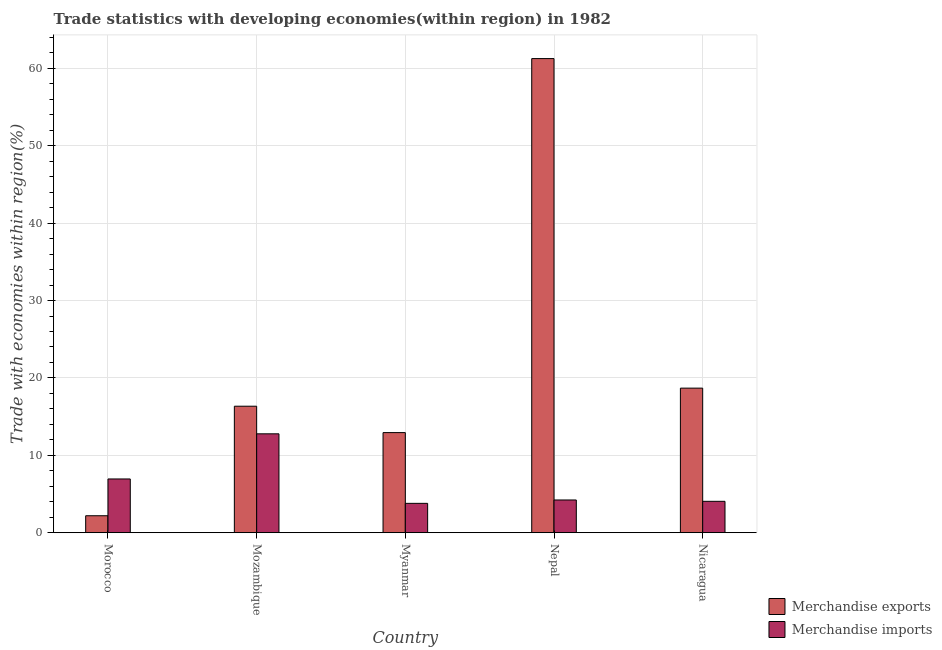How many bars are there on the 2nd tick from the left?
Your response must be concise. 2. How many bars are there on the 4th tick from the right?
Provide a succinct answer. 2. What is the label of the 2nd group of bars from the left?
Your answer should be very brief. Mozambique. What is the merchandise exports in Myanmar?
Make the answer very short. 12.94. Across all countries, what is the maximum merchandise exports?
Your response must be concise. 61.26. Across all countries, what is the minimum merchandise imports?
Offer a terse response. 3.79. In which country was the merchandise imports maximum?
Ensure brevity in your answer.  Mozambique. In which country was the merchandise imports minimum?
Ensure brevity in your answer.  Myanmar. What is the total merchandise imports in the graph?
Offer a very short reply. 31.8. What is the difference between the merchandise exports in Morocco and that in Myanmar?
Make the answer very short. -10.74. What is the difference between the merchandise imports in Nepal and the merchandise exports in Mozambique?
Provide a short and direct response. -12.12. What is the average merchandise exports per country?
Your answer should be compact. 22.28. What is the difference between the merchandise exports and merchandise imports in Nepal?
Your answer should be very brief. 57.03. What is the ratio of the merchandise exports in Morocco to that in Nepal?
Offer a very short reply. 0.04. What is the difference between the highest and the second highest merchandise imports?
Make the answer very short. 5.83. What is the difference between the highest and the lowest merchandise imports?
Offer a very short reply. 8.98. In how many countries, is the merchandise exports greater than the average merchandise exports taken over all countries?
Your answer should be compact. 1. Is the sum of the merchandise exports in Mozambique and Nicaragua greater than the maximum merchandise imports across all countries?
Your response must be concise. Yes. What does the 1st bar from the right in Nicaragua represents?
Your answer should be very brief. Merchandise imports. How many countries are there in the graph?
Keep it short and to the point. 5. What is the difference between two consecutive major ticks on the Y-axis?
Provide a short and direct response. 10. What is the title of the graph?
Your answer should be very brief. Trade statistics with developing economies(within region) in 1982. What is the label or title of the X-axis?
Ensure brevity in your answer.  Country. What is the label or title of the Y-axis?
Your answer should be very brief. Trade with economies within region(%). What is the Trade with economies within region(%) of Merchandise exports in Morocco?
Your answer should be compact. 2.19. What is the Trade with economies within region(%) in Merchandise imports in Morocco?
Make the answer very short. 6.94. What is the Trade with economies within region(%) of Merchandise exports in Mozambique?
Provide a succinct answer. 16.35. What is the Trade with economies within region(%) of Merchandise imports in Mozambique?
Ensure brevity in your answer.  12.78. What is the Trade with economies within region(%) in Merchandise exports in Myanmar?
Keep it short and to the point. 12.94. What is the Trade with economies within region(%) in Merchandise imports in Myanmar?
Your answer should be very brief. 3.79. What is the Trade with economies within region(%) of Merchandise exports in Nepal?
Provide a short and direct response. 61.26. What is the Trade with economies within region(%) of Merchandise imports in Nepal?
Keep it short and to the point. 4.23. What is the Trade with economies within region(%) in Merchandise exports in Nicaragua?
Keep it short and to the point. 18.68. What is the Trade with economies within region(%) in Merchandise imports in Nicaragua?
Ensure brevity in your answer.  4.05. Across all countries, what is the maximum Trade with economies within region(%) of Merchandise exports?
Provide a short and direct response. 61.26. Across all countries, what is the maximum Trade with economies within region(%) of Merchandise imports?
Offer a terse response. 12.78. Across all countries, what is the minimum Trade with economies within region(%) in Merchandise exports?
Your response must be concise. 2.19. Across all countries, what is the minimum Trade with economies within region(%) of Merchandise imports?
Make the answer very short. 3.79. What is the total Trade with economies within region(%) in Merchandise exports in the graph?
Ensure brevity in your answer.  111.41. What is the total Trade with economies within region(%) in Merchandise imports in the graph?
Make the answer very short. 31.8. What is the difference between the Trade with economies within region(%) in Merchandise exports in Morocco and that in Mozambique?
Keep it short and to the point. -14.15. What is the difference between the Trade with economies within region(%) of Merchandise imports in Morocco and that in Mozambique?
Offer a very short reply. -5.83. What is the difference between the Trade with economies within region(%) of Merchandise exports in Morocco and that in Myanmar?
Your answer should be compact. -10.74. What is the difference between the Trade with economies within region(%) in Merchandise imports in Morocco and that in Myanmar?
Provide a short and direct response. 3.15. What is the difference between the Trade with economies within region(%) of Merchandise exports in Morocco and that in Nepal?
Your response must be concise. -59.07. What is the difference between the Trade with economies within region(%) of Merchandise imports in Morocco and that in Nepal?
Ensure brevity in your answer.  2.72. What is the difference between the Trade with economies within region(%) in Merchandise exports in Morocco and that in Nicaragua?
Your response must be concise. -16.49. What is the difference between the Trade with economies within region(%) in Merchandise imports in Morocco and that in Nicaragua?
Ensure brevity in your answer.  2.89. What is the difference between the Trade with economies within region(%) in Merchandise exports in Mozambique and that in Myanmar?
Offer a terse response. 3.41. What is the difference between the Trade with economies within region(%) in Merchandise imports in Mozambique and that in Myanmar?
Give a very brief answer. 8.98. What is the difference between the Trade with economies within region(%) in Merchandise exports in Mozambique and that in Nepal?
Offer a very short reply. -44.91. What is the difference between the Trade with economies within region(%) of Merchandise imports in Mozambique and that in Nepal?
Provide a succinct answer. 8.55. What is the difference between the Trade with economies within region(%) in Merchandise exports in Mozambique and that in Nicaragua?
Your response must be concise. -2.34. What is the difference between the Trade with economies within region(%) in Merchandise imports in Mozambique and that in Nicaragua?
Make the answer very short. 8.72. What is the difference between the Trade with economies within region(%) in Merchandise exports in Myanmar and that in Nepal?
Your answer should be compact. -48.32. What is the difference between the Trade with economies within region(%) of Merchandise imports in Myanmar and that in Nepal?
Keep it short and to the point. -0.44. What is the difference between the Trade with economies within region(%) of Merchandise exports in Myanmar and that in Nicaragua?
Offer a terse response. -5.75. What is the difference between the Trade with economies within region(%) in Merchandise imports in Myanmar and that in Nicaragua?
Your answer should be compact. -0.26. What is the difference between the Trade with economies within region(%) of Merchandise exports in Nepal and that in Nicaragua?
Ensure brevity in your answer.  42.58. What is the difference between the Trade with economies within region(%) in Merchandise imports in Nepal and that in Nicaragua?
Provide a succinct answer. 0.17. What is the difference between the Trade with economies within region(%) in Merchandise exports in Morocco and the Trade with economies within region(%) in Merchandise imports in Mozambique?
Make the answer very short. -10.58. What is the difference between the Trade with economies within region(%) in Merchandise exports in Morocco and the Trade with economies within region(%) in Merchandise imports in Myanmar?
Keep it short and to the point. -1.6. What is the difference between the Trade with economies within region(%) of Merchandise exports in Morocco and the Trade with economies within region(%) of Merchandise imports in Nepal?
Your response must be concise. -2.04. What is the difference between the Trade with economies within region(%) in Merchandise exports in Morocco and the Trade with economies within region(%) in Merchandise imports in Nicaragua?
Offer a very short reply. -1.86. What is the difference between the Trade with economies within region(%) of Merchandise exports in Mozambique and the Trade with economies within region(%) of Merchandise imports in Myanmar?
Keep it short and to the point. 12.55. What is the difference between the Trade with economies within region(%) of Merchandise exports in Mozambique and the Trade with economies within region(%) of Merchandise imports in Nepal?
Provide a short and direct response. 12.12. What is the difference between the Trade with economies within region(%) in Merchandise exports in Mozambique and the Trade with economies within region(%) in Merchandise imports in Nicaragua?
Keep it short and to the point. 12.29. What is the difference between the Trade with economies within region(%) in Merchandise exports in Myanmar and the Trade with economies within region(%) in Merchandise imports in Nepal?
Keep it short and to the point. 8.71. What is the difference between the Trade with economies within region(%) in Merchandise exports in Myanmar and the Trade with economies within region(%) in Merchandise imports in Nicaragua?
Your answer should be compact. 8.88. What is the difference between the Trade with economies within region(%) in Merchandise exports in Nepal and the Trade with economies within region(%) in Merchandise imports in Nicaragua?
Provide a short and direct response. 57.2. What is the average Trade with economies within region(%) in Merchandise exports per country?
Keep it short and to the point. 22.28. What is the average Trade with economies within region(%) in Merchandise imports per country?
Make the answer very short. 6.36. What is the difference between the Trade with economies within region(%) of Merchandise exports and Trade with economies within region(%) of Merchandise imports in Morocco?
Offer a terse response. -4.75. What is the difference between the Trade with economies within region(%) of Merchandise exports and Trade with economies within region(%) of Merchandise imports in Mozambique?
Offer a terse response. 3.57. What is the difference between the Trade with economies within region(%) of Merchandise exports and Trade with economies within region(%) of Merchandise imports in Myanmar?
Provide a succinct answer. 9.14. What is the difference between the Trade with economies within region(%) in Merchandise exports and Trade with economies within region(%) in Merchandise imports in Nepal?
Ensure brevity in your answer.  57.03. What is the difference between the Trade with economies within region(%) of Merchandise exports and Trade with economies within region(%) of Merchandise imports in Nicaragua?
Provide a short and direct response. 14.63. What is the ratio of the Trade with economies within region(%) of Merchandise exports in Morocco to that in Mozambique?
Your answer should be compact. 0.13. What is the ratio of the Trade with economies within region(%) of Merchandise imports in Morocco to that in Mozambique?
Offer a terse response. 0.54. What is the ratio of the Trade with economies within region(%) in Merchandise exports in Morocco to that in Myanmar?
Give a very brief answer. 0.17. What is the ratio of the Trade with economies within region(%) in Merchandise imports in Morocco to that in Myanmar?
Provide a succinct answer. 1.83. What is the ratio of the Trade with economies within region(%) in Merchandise exports in Morocco to that in Nepal?
Offer a terse response. 0.04. What is the ratio of the Trade with economies within region(%) of Merchandise imports in Morocco to that in Nepal?
Your answer should be compact. 1.64. What is the ratio of the Trade with economies within region(%) of Merchandise exports in Morocco to that in Nicaragua?
Ensure brevity in your answer.  0.12. What is the ratio of the Trade with economies within region(%) in Merchandise imports in Morocco to that in Nicaragua?
Your answer should be compact. 1.71. What is the ratio of the Trade with economies within region(%) of Merchandise exports in Mozambique to that in Myanmar?
Your answer should be compact. 1.26. What is the ratio of the Trade with economies within region(%) in Merchandise imports in Mozambique to that in Myanmar?
Provide a short and direct response. 3.37. What is the ratio of the Trade with economies within region(%) in Merchandise exports in Mozambique to that in Nepal?
Offer a terse response. 0.27. What is the ratio of the Trade with economies within region(%) of Merchandise imports in Mozambique to that in Nepal?
Offer a very short reply. 3.02. What is the ratio of the Trade with economies within region(%) in Merchandise exports in Mozambique to that in Nicaragua?
Provide a short and direct response. 0.88. What is the ratio of the Trade with economies within region(%) of Merchandise imports in Mozambique to that in Nicaragua?
Your response must be concise. 3.15. What is the ratio of the Trade with economies within region(%) in Merchandise exports in Myanmar to that in Nepal?
Provide a short and direct response. 0.21. What is the ratio of the Trade with economies within region(%) in Merchandise imports in Myanmar to that in Nepal?
Keep it short and to the point. 0.9. What is the ratio of the Trade with economies within region(%) of Merchandise exports in Myanmar to that in Nicaragua?
Your response must be concise. 0.69. What is the ratio of the Trade with economies within region(%) in Merchandise imports in Myanmar to that in Nicaragua?
Provide a succinct answer. 0.94. What is the ratio of the Trade with economies within region(%) of Merchandise exports in Nepal to that in Nicaragua?
Your response must be concise. 3.28. What is the ratio of the Trade with economies within region(%) in Merchandise imports in Nepal to that in Nicaragua?
Ensure brevity in your answer.  1.04. What is the difference between the highest and the second highest Trade with economies within region(%) in Merchandise exports?
Provide a succinct answer. 42.58. What is the difference between the highest and the second highest Trade with economies within region(%) of Merchandise imports?
Give a very brief answer. 5.83. What is the difference between the highest and the lowest Trade with economies within region(%) in Merchandise exports?
Your answer should be very brief. 59.07. What is the difference between the highest and the lowest Trade with economies within region(%) of Merchandise imports?
Your answer should be compact. 8.98. 